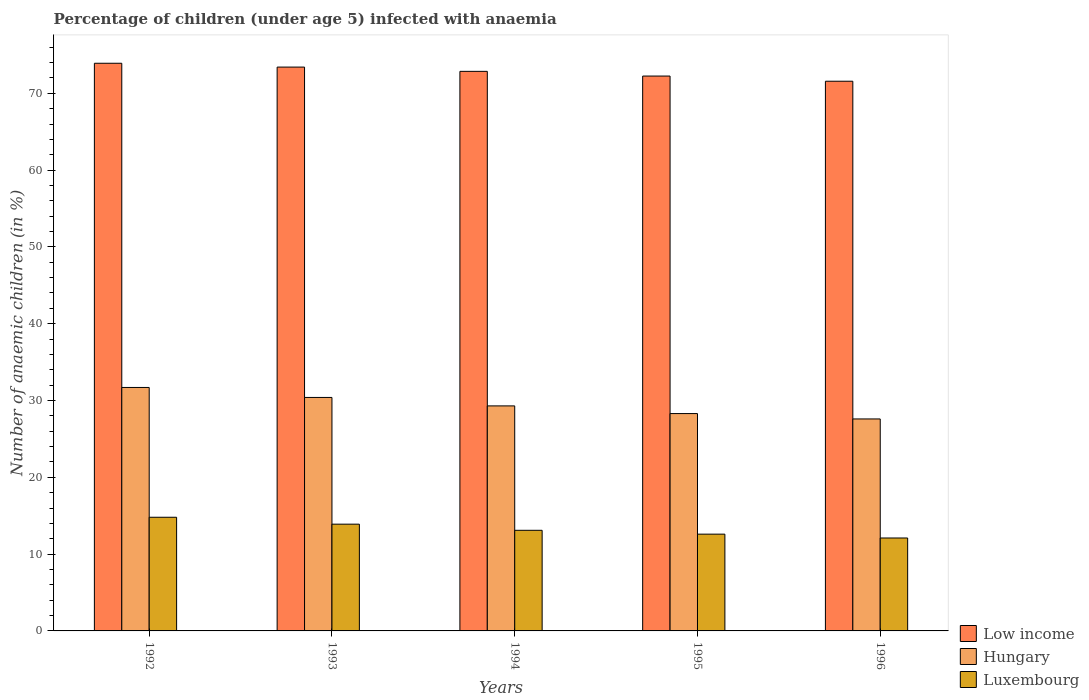How many different coloured bars are there?
Your answer should be compact. 3. Are the number of bars per tick equal to the number of legend labels?
Make the answer very short. Yes. How many bars are there on the 2nd tick from the left?
Offer a terse response. 3. Across all years, what is the maximum percentage of children infected with anaemia in in Luxembourg?
Keep it short and to the point. 14.8. Across all years, what is the minimum percentage of children infected with anaemia in in Hungary?
Give a very brief answer. 27.6. In which year was the percentage of children infected with anaemia in in Hungary maximum?
Offer a terse response. 1992. In which year was the percentage of children infected with anaemia in in Low income minimum?
Ensure brevity in your answer.  1996. What is the total percentage of children infected with anaemia in in Low income in the graph?
Your answer should be compact. 364.01. What is the difference between the percentage of children infected with anaemia in in Hungary in 1992 and that in 1993?
Ensure brevity in your answer.  1.3. What is the difference between the percentage of children infected with anaemia in in Low income in 1992 and the percentage of children infected with anaemia in in Hungary in 1995?
Keep it short and to the point. 45.61. What is the average percentage of children infected with anaemia in in Hungary per year?
Your answer should be very brief. 29.46. In the year 1992, what is the difference between the percentage of children infected with anaemia in in Low income and percentage of children infected with anaemia in in Luxembourg?
Provide a short and direct response. 59.11. What is the ratio of the percentage of children infected with anaemia in in Low income in 1992 to that in 1995?
Ensure brevity in your answer.  1.02. Is the percentage of children infected with anaemia in in Hungary in 1992 less than that in 1995?
Keep it short and to the point. No. What is the difference between the highest and the second highest percentage of children infected with anaemia in in Low income?
Offer a terse response. 0.5. What is the difference between the highest and the lowest percentage of children infected with anaemia in in Luxembourg?
Keep it short and to the point. 2.7. What does the 3rd bar from the left in 1992 represents?
Make the answer very short. Luxembourg. What does the 1st bar from the right in 1995 represents?
Provide a succinct answer. Luxembourg. How many bars are there?
Give a very brief answer. 15. How many years are there in the graph?
Provide a short and direct response. 5. What is the difference between two consecutive major ticks on the Y-axis?
Your response must be concise. 10. Are the values on the major ticks of Y-axis written in scientific E-notation?
Give a very brief answer. No. Does the graph contain any zero values?
Keep it short and to the point. No. Where does the legend appear in the graph?
Your response must be concise. Bottom right. What is the title of the graph?
Your answer should be compact. Percentage of children (under age 5) infected with anaemia. What is the label or title of the Y-axis?
Your answer should be very brief. Number of anaemic children (in %). What is the Number of anaemic children (in %) of Low income in 1992?
Keep it short and to the point. 73.91. What is the Number of anaemic children (in %) in Hungary in 1992?
Make the answer very short. 31.7. What is the Number of anaemic children (in %) of Low income in 1993?
Offer a very short reply. 73.41. What is the Number of anaemic children (in %) in Hungary in 1993?
Ensure brevity in your answer.  30.4. What is the Number of anaemic children (in %) of Luxembourg in 1993?
Give a very brief answer. 13.9. What is the Number of anaemic children (in %) of Low income in 1994?
Provide a succinct answer. 72.86. What is the Number of anaemic children (in %) in Hungary in 1994?
Provide a short and direct response. 29.3. What is the Number of anaemic children (in %) in Low income in 1995?
Your response must be concise. 72.25. What is the Number of anaemic children (in %) in Hungary in 1995?
Provide a succinct answer. 28.3. What is the Number of anaemic children (in %) of Low income in 1996?
Your answer should be compact. 71.57. What is the Number of anaemic children (in %) in Hungary in 1996?
Give a very brief answer. 27.6. What is the Number of anaemic children (in %) in Luxembourg in 1996?
Keep it short and to the point. 12.1. Across all years, what is the maximum Number of anaemic children (in %) in Low income?
Make the answer very short. 73.91. Across all years, what is the maximum Number of anaemic children (in %) of Hungary?
Offer a terse response. 31.7. Across all years, what is the minimum Number of anaemic children (in %) in Low income?
Give a very brief answer. 71.57. Across all years, what is the minimum Number of anaemic children (in %) of Hungary?
Offer a very short reply. 27.6. Across all years, what is the minimum Number of anaemic children (in %) of Luxembourg?
Ensure brevity in your answer.  12.1. What is the total Number of anaemic children (in %) of Low income in the graph?
Provide a short and direct response. 364.01. What is the total Number of anaemic children (in %) in Hungary in the graph?
Make the answer very short. 147.3. What is the total Number of anaemic children (in %) of Luxembourg in the graph?
Your answer should be compact. 66.5. What is the difference between the Number of anaemic children (in %) of Low income in 1992 and that in 1993?
Your response must be concise. 0.5. What is the difference between the Number of anaemic children (in %) of Low income in 1992 and that in 1994?
Provide a short and direct response. 1.05. What is the difference between the Number of anaemic children (in %) in Hungary in 1992 and that in 1994?
Offer a very short reply. 2.4. What is the difference between the Number of anaemic children (in %) in Low income in 1992 and that in 1995?
Provide a short and direct response. 1.67. What is the difference between the Number of anaemic children (in %) of Hungary in 1992 and that in 1995?
Your answer should be compact. 3.4. What is the difference between the Number of anaemic children (in %) of Low income in 1992 and that in 1996?
Ensure brevity in your answer.  2.34. What is the difference between the Number of anaemic children (in %) of Low income in 1993 and that in 1994?
Your answer should be compact. 0.56. What is the difference between the Number of anaemic children (in %) in Hungary in 1993 and that in 1994?
Your answer should be compact. 1.1. What is the difference between the Number of anaemic children (in %) of Luxembourg in 1993 and that in 1994?
Keep it short and to the point. 0.8. What is the difference between the Number of anaemic children (in %) of Low income in 1993 and that in 1995?
Provide a succinct answer. 1.17. What is the difference between the Number of anaemic children (in %) of Low income in 1993 and that in 1996?
Your answer should be compact. 1.84. What is the difference between the Number of anaemic children (in %) of Low income in 1994 and that in 1995?
Your answer should be very brief. 0.61. What is the difference between the Number of anaemic children (in %) in Low income in 1994 and that in 1996?
Your response must be concise. 1.28. What is the difference between the Number of anaemic children (in %) of Low income in 1995 and that in 1996?
Your answer should be compact. 0.67. What is the difference between the Number of anaemic children (in %) of Hungary in 1995 and that in 1996?
Give a very brief answer. 0.7. What is the difference between the Number of anaemic children (in %) of Low income in 1992 and the Number of anaemic children (in %) of Hungary in 1993?
Give a very brief answer. 43.51. What is the difference between the Number of anaemic children (in %) of Low income in 1992 and the Number of anaemic children (in %) of Luxembourg in 1993?
Provide a short and direct response. 60.01. What is the difference between the Number of anaemic children (in %) in Hungary in 1992 and the Number of anaemic children (in %) in Luxembourg in 1993?
Provide a short and direct response. 17.8. What is the difference between the Number of anaemic children (in %) in Low income in 1992 and the Number of anaemic children (in %) in Hungary in 1994?
Ensure brevity in your answer.  44.61. What is the difference between the Number of anaemic children (in %) of Low income in 1992 and the Number of anaemic children (in %) of Luxembourg in 1994?
Provide a short and direct response. 60.81. What is the difference between the Number of anaemic children (in %) of Hungary in 1992 and the Number of anaemic children (in %) of Luxembourg in 1994?
Your response must be concise. 18.6. What is the difference between the Number of anaemic children (in %) in Low income in 1992 and the Number of anaemic children (in %) in Hungary in 1995?
Your response must be concise. 45.61. What is the difference between the Number of anaemic children (in %) in Low income in 1992 and the Number of anaemic children (in %) in Luxembourg in 1995?
Offer a very short reply. 61.31. What is the difference between the Number of anaemic children (in %) of Low income in 1992 and the Number of anaemic children (in %) of Hungary in 1996?
Offer a terse response. 46.31. What is the difference between the Number of anaemic children (in %) of Low income in 1992 and the Number of anaemic children (in %) of Luxembourg in 1996?
Your response must be concise. 61.81. What is the difference between the Number of anaemic children (in %) in Hungary in 1992 and the Number of anaemic children (in %) in Luxembourg in 1996?
Your response must be concise. 19.6. What is the difference between the Number of anaemic children (in %) in Low income in 1993 and the Number of anaemic children (in %) in Hungary in 1994?
Your answer should be compact. 44.11. What is the difference between the Number of anaemic children (in %) in Low income in 1993 and the Number of anaemic children (in %) in Luxembourg in 1994?
Give a very brief answer. 60.31. What is the difference between the Number of anaemic children (in %) in Low income in 1993 and the Number of anaemic children (in %) in Hungary in 1995?
Offer a very short reply. 45.11. What is the difference between the Number of anaemic children (in %) in Low income in 1993 and the Number of anaemic children (in %) in Luxembourg in 1995?
Your response must be concise. 60.81. What is the difference between the Number of anaemic children (in %) of Hungary in 1993 and the Number of anaemic children (in %) of Luxembourg in 1995?
Your answer should be compact. 17.8. What is the difference between the Number of anaemic children (in %) of Low income in 1993 and the Number of anaemic children (in %) of Hungary in 1996?
Your answer should be compact. 45.81. What is the difference between the Number of anaemic children (in %) in Low income in 1993 and the Number of anaemic children (in %) in Luxembourg in 1996?
Provide a succinct answer. 61.31. What is the difference between the Number of anaemic children (in %) in Hungary in 1993 and the Number of anaemic children (in %) in Luxembourg in 1996?
Provide a succinct answer. 18.3. What is the difference between the Number of anaemic children (in %) of Low income in 1994 and the Number of anaemic children (in %) of Hungary in 1995?
Offer a very short reply. 44.56. What is the difference between the Number of anaemic children (in %) in Low income in 1994 and the Number of anaemic children (in %) in Luxembourg in 1995?
Offer a very short reply. 60.26. What is the difference between the Number of anaemic children (in %) of Hungary in 1994 and the Number of anaemic children (in %) of Luxembourg in 1995?
Provide a short and direct response. 16.7. What is the difference between the Number of anaemic children (in %) in Low income in 1994 and the Number of anaemic children (in %) in Hungary in 1996?
Your answer should be very brief. 45.26. What is the difference between the Number of anaemic children (in %) of Low income in 1994 and the Number of anaemic children (in %) of Luxembourg in 1996?
Your response must be concise. 60.76. What is the difference between the Number of anaemic children (in %) of Hungary in 1994 and the Number of anaemic children (in %) of Luxembourg in 1996?
Keep it short and to the point. 17.2. What is the difference between the Number of anaemic children (in %) of Low income in 1995 and the Number of anaemic children (in %) of Hungary in 1996?
Offer a terse response. 44.65. What is the difference between the Number of anaemic children (in %) in Low income in 1995 and the Number of anaemic children (in %) in Luxembourg in 1996?
Provide a short and direct response. 60.15. What is the average Number of anaemic children (in %) in Low income per year?
Ensure brevity in your answer.  72.8. What is the average Number of anaemic children (in %) in Hungary per year?
Your response must be concise. 29.46. What is the average Number of anaemic children (in %) of Luxembourg per year?
Your answer should be compact. 13.3. In the year 1992, what is the difference between the Number of anaemic children (in %) of Low income and Number of anaemic children (in %) of Hungary?
Provide a short and direct response. 42.21. In the year 1992, what is the difference between the Number of anaemic children (in %) of Low income and Number of anaemic children (in %) of Luxembourg?
Your response must be concise. 59.11. In the year 1993, what is the difference between the Number of anaemic children (in %) of Low income and Number of anaemic children (in %) of Hungary?
Your answer should be very brief. 43.01. In the year 1993, what is the difference between the Number of anaemic children (in %) in Low income and Number of anaemic children (in %) in Luxembourg?
Your answer should be very brief. 59.51. In the year 1994, what is the difference between the Number of anaemic children (in %) of Low income and Number of anaemic children (in %) of Hungary?
Offer a very short reply. 43.56. In the year 1994, what is the difference between the Number of anaemic children (in %) of Low income and Number of anaemic children (in %) of Luxembourg?
Ensure brevity in your answer.  59.76. In the year 1994, what is the difference between the Number of anaemic children (in %) in Hungary and Number of anaemic children (in %) in Luxembourg?
Provide a succinct answer. 16.2. In the year 1995, what is the difference between the Number of anaemic children (in %) of Low income and Number of anaemic children (in %) of Hungary?
Make the answer very short. 43.95. In the year 1995, what is the difference between the Number of anaemic children (in %) of Low income and Number of anaemic children (in %) of Luxembourg?
Ensure brevity in your answer.  59.65. In the year 1996, what is the difference between the Number of anaemic children (in %) of Low income and Number of anaemic children (in %) of Hungary?
Offer a terse response. 43.97. In the year 1996, what is the difference between the Number of anaemic children (in %) in Low income and Number of anaemic children (in %) in Luxembourg?
Ensure brevity in your answer.  59.47. In the year 1996, what is the difference between the Number of anaemic children (in %) in Hungary and Number of anaemic children (in %) in Luxembourg?
Your answer should be compact. 15.5. What is the ratio of the Number of anaemic children (in %) in Low income in 1992 to that in 1993?
Provide a succinct answer. 1.01. What is the ratio of the Number of anaemic children (in %) of Hungary in 1992 to that in 1993?
Provide a short and direct response. 1.04. What is the ratio of the Number of anaemic children (in %) of Luxembourg in 1992 to that in 1993?
Provide a succinct answer. 1.06. What is the ratio of the Number of anaemic children (in %) in Low income in 1992 to that in 1994?
Ensure brevity in your answer.  1.01. What is the ratio of the Number of anaemic children (in %) in Hungary in 1992 to that in 1994?
Give a very brief answer. 1.08. What is the ratio of the Number of anaemic children (in %) of Luxembourg in 1992 to that in 1994?
Make the answer very short. 1.13. What is the ratio of the Number of anaemic children (in %) of Low income in 1992 to that in 1995?
Provide a succinct answer. 1.02. What is the ratio of the Number of anaemic children (in %) of Hungary in 1992 to that in 1995?
Your answer should be very brief. 1.12. What is the ratio of the Number of anaemic children (in %) of Luxembourg in 1992 to that in 1995?
Your answer should be compact. 1.17. What is the ratio of the Number of anaemic children (in %) in Low income in 1992 to that in 1996?
Ensure brevity in your answer.  1.03. What is the ratio of the Number of anaemic children (in %) of Hungary in 1992 to that in 1996?
Give a very brief answer. 1.15. What is the ratio of the Number of anaemic children (in %) in Luxembourg in 1992 to that in 1996?
Give a very brief answer. 1.22. What is the ratio of the Number of anaemic children (in %) of Low income in 1993 to that in 1994?
Provide a short and direct response. 1.01. What is the ratio of the Number of anaemic children (in %) in Hungary in 1993 to that in 1994?
Provide a succinct answer. 1.04. What is the ratio of the Number of anaemic children (in %) in Luxembourg in 1993 to that in 1994?
Offer a very short reply. 1.06. What is the ratio of the Number of anaemic children (in %) in Low income in 1993 to that in 1995?
Your answer should be very brief. 1.02. What is the ratio of the Number of anaemic children (in %) of Hungary in 1993 to that in 1995?
Ensure brevity in your answer.  1.07. What is the ratio of the Number of anaemic children (in %) of Luxembourg in 1993 to that in 1995?
Your answer should be compact. 1.1. What is the ratio of the Number of anaemic children (in %) in Low income in 1993 to that in 1996?
Keep it short and to the point. 1.03. What is the ratio of the Number of anaemic children (in %) of Hungary in 1993 to that in 1996?
Provide a succinct answer. 1.1. What is the ratio of the Number of anaemic children (in %) in Luxembourg in 1993 to that in 1996?
Ensure brevity in your answer.  1.15. What is the ratio of the Number of anaemic children (in %) of Low income in 1994 to that in 1995?
Your answer should be compact. 1.01. What is the ratio of the Number of anaemic children (in %) in Hungary in 1994 to that in 1995?
Make the answer very short. 1.04. What is the ratio of the Number of anaemic children (in %) in Luxembourg in 1994 to that in 1995?
Provide a succinct answer. 1.04. What is the ratio of the Number of anaemic children (in %) in Low income in 1994 to that in 1996?
Make the answer very short. 1.02. What is the ratio of the Number of anaemic children (in %) in Hungary in 1994 to that in 1996?
Your answer should be compact. 1.06. What is the ratio of the Number of anaemic children (in %) of Luxembourg in 1994 to that in 1996?
Give a very brief answer. 1.08. What is the ratio of the Number of anaemic children (in %) of Low income in 1995 to that in 1996?
Provide a short and direct response. 1.01. What is the ratio of the Number of anaemic children (in %) in Hungary in 1995 to that in 1996?
Ensure brevity in your answer.  1.03. What is the ratio of the Number of anaemic children (in %) in Luxembourg in 1995 to that in 1996?
Make the answer very short. 1.04. What is the difference between the highest and the second highest Number of anaemic children (in %) of Low income?
Give a very brief answer. 0.5. What is the difference between the highest and the second highest Number of anaemic children (in %) in Luxembourg?
Give a very brief answer. 0.9. What is the difference between the highest and the lowest Number of anaemic children (in %) of Low income?
Offer a very short reply. 2.34. What is the difference between the highest and the lowest Number of anaemic children (in %) in Hungary?
Ensure brevity in your answer.  4.1. 